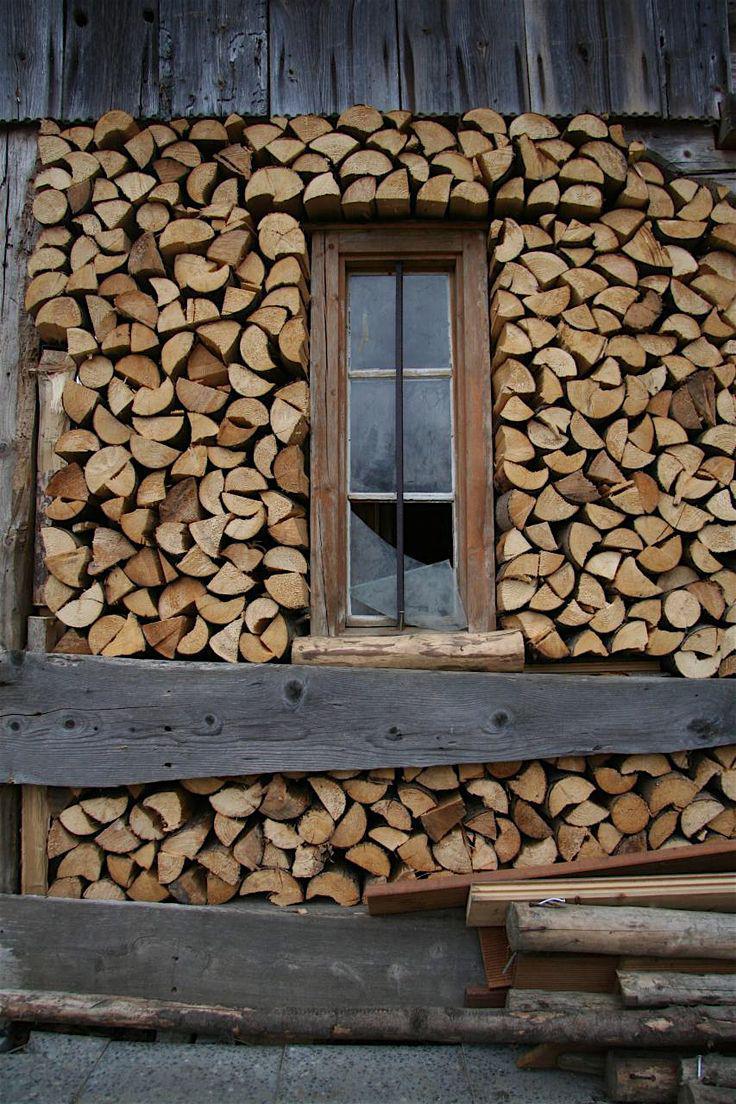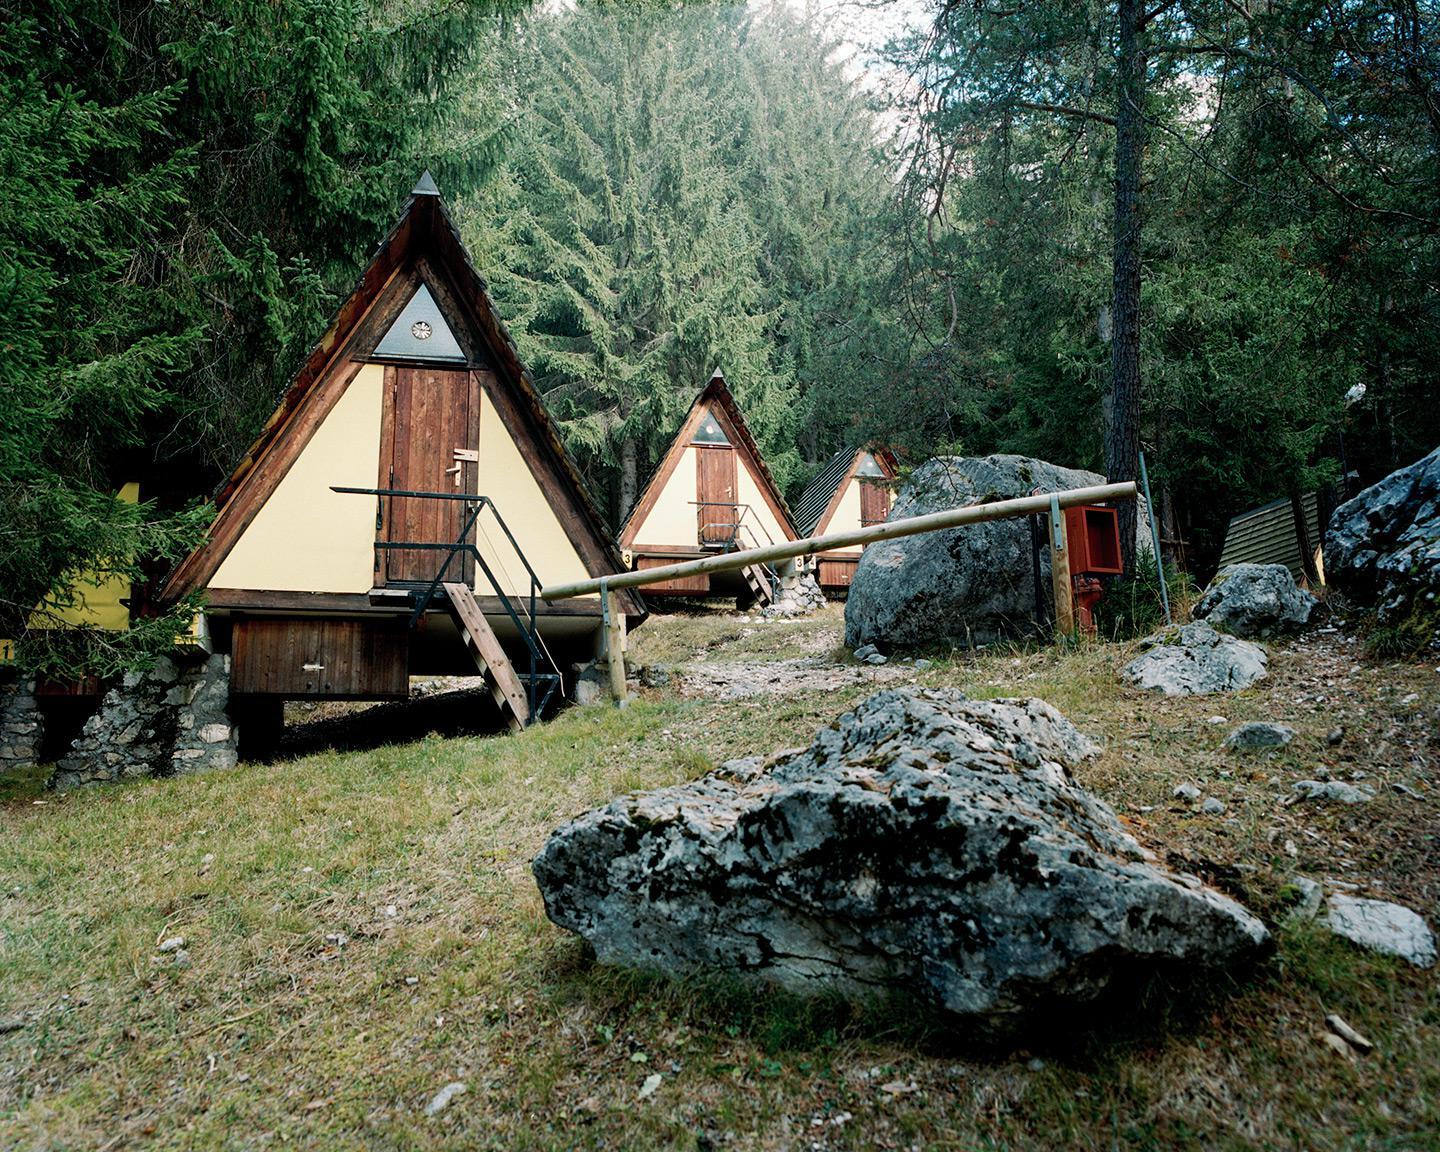The first image is the image on the left, the second image is the image on the right. Considering the images on both sides, is "The crosshatched pattern of the wood structure is clearly visible in at least one of the images." valid? Answer yes or no. No. 